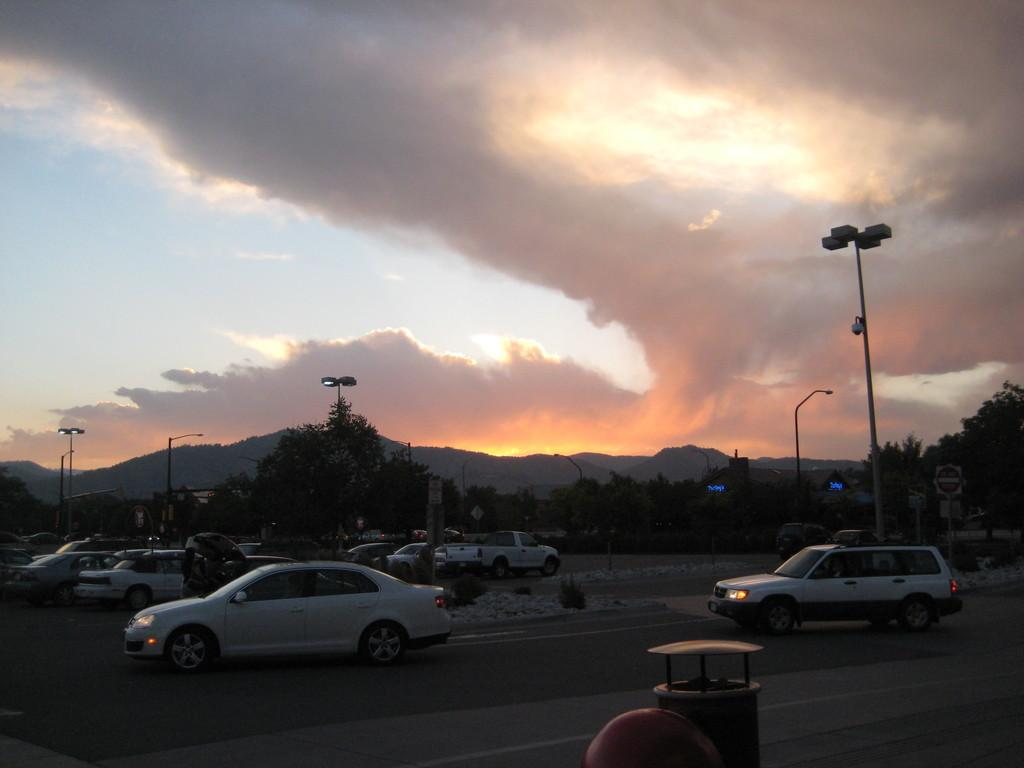What can be seen in the image? There are many vehicles, a road, light poles, trees, a hill, and the sky visible in the image. Can you describe the road in the image? The road is in the image, and it is likely where the vehicles are traveling. What is present in the background of the image? In the background of the image, there are trees and a hill. What is visible in the sky? The sky is visible in the image, and there are clouds present. What type of invention is being demonstrated on the hill in the image? There is no invention being demonstrated in the image; it features vehicles, a road, light poles, trees, a hill, and the sky with clouds. What type of beef is being served at the picnic table in the image? There is no picnic table or beef present in the image. 